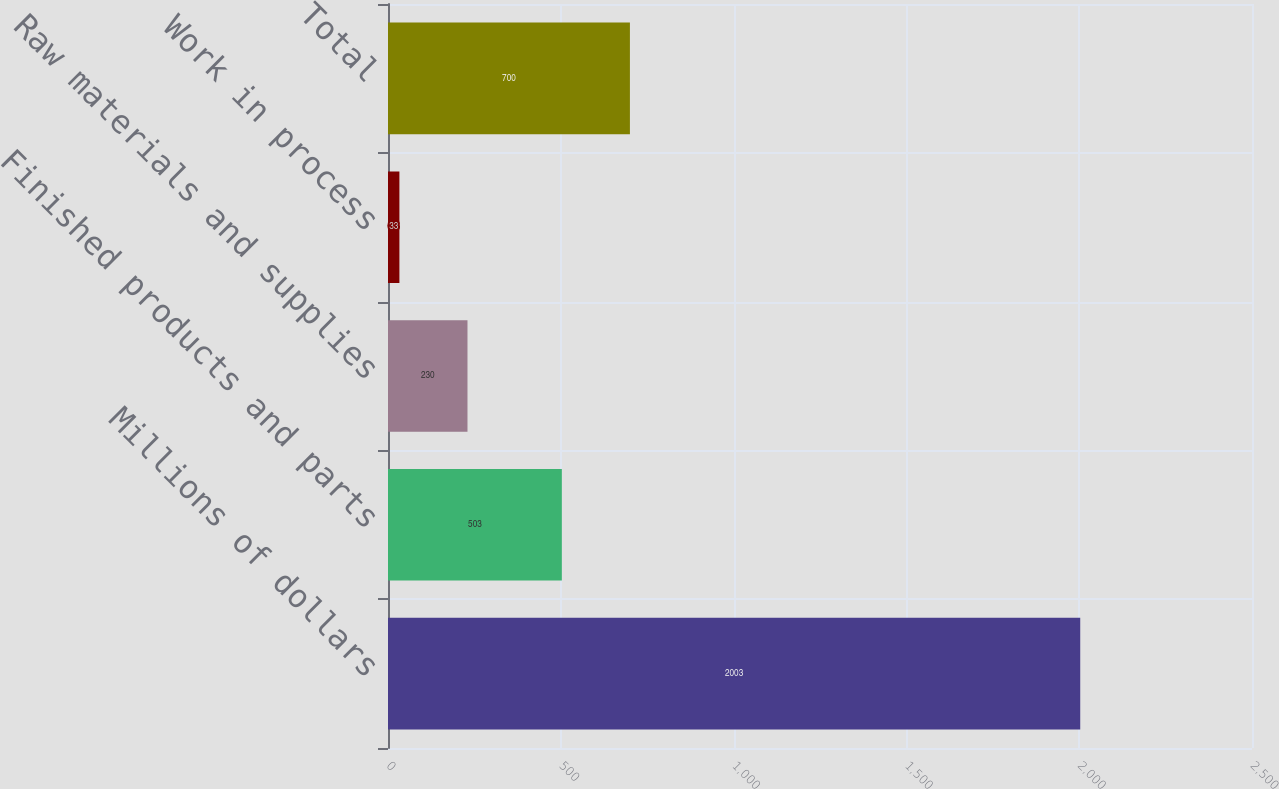Convert chart to OTSL. <chart><loc_0><loc_0><loc_500><loc_500><bar_chart><fcel>Millions of dollars<fcel>Finished products and parts<fcel>Raw materials and supplies<fcel>Work in process<fcel>Total<nl><fcel>2003<fcel>503<fcel>230<fcel>33<fcel>700<nl></chart> 